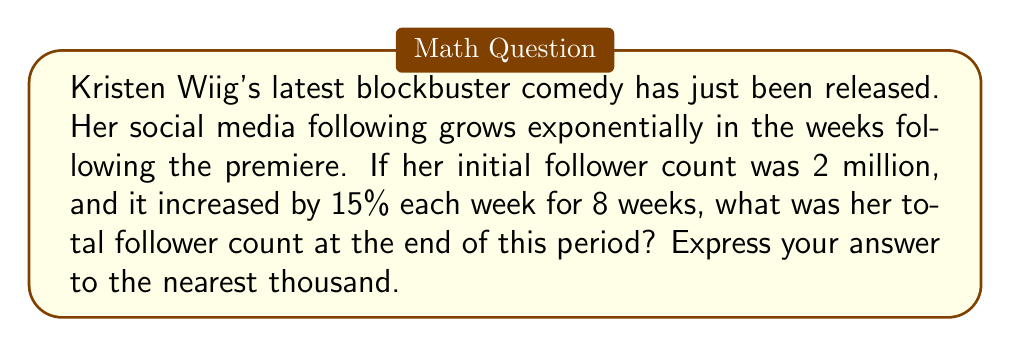Teach me how to tackle this problem. To solve this problem, we need to use the formula for exponential growth:

$$A = P(1 + r)^n$$

Where:
$A$ = final amount
$P$ = initial principal balance
$r$ = growth rate (as a decimal)
$n$ = number of time periods

Given:
$P = 2,000,000$ (initial follower count)
$r = 0.15$ (15% growth rate)
$n = 8$ (weeks)

Let's plug these values into our formula:

$$A = 2,000,000(1 + 0.15)^8$$

$$A = 2,000,000(1.15)^8$$

Now, let's calculate $(1.15)^8$:

$$(1.15)^8 = 3.0590$$

Multiplying this by our initial follower count:

$$A = 2,000,000 \times 3.0590 = 6,118,000$$

Rounding to the nearest thousand:

$$A \approx 6,118,000$$
Answer: 6,118,000 followers 